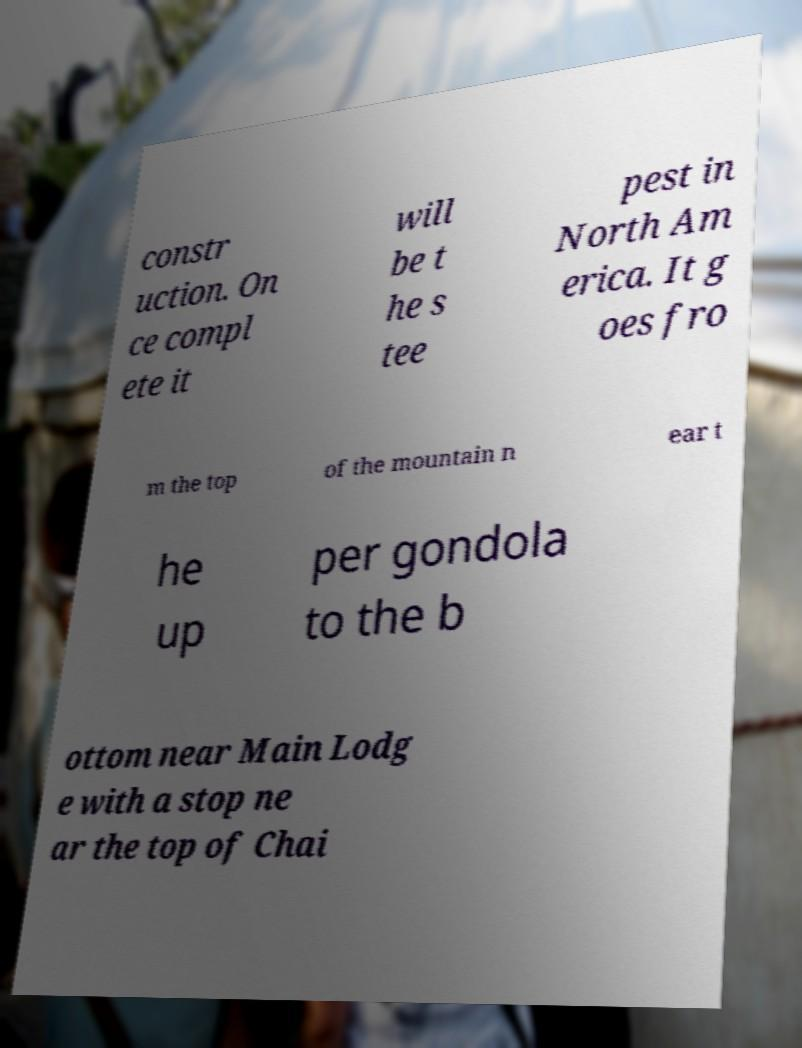Can you accurately transcribe the text from the provided image for me? constr uction. On ce compl ete it will be t he s tee pest in North Am erica. It g oes fro m the top of the mountain n ear t he up per gondola to the b ottom near Main Lodg e with a stop ne ar the top of Chai 